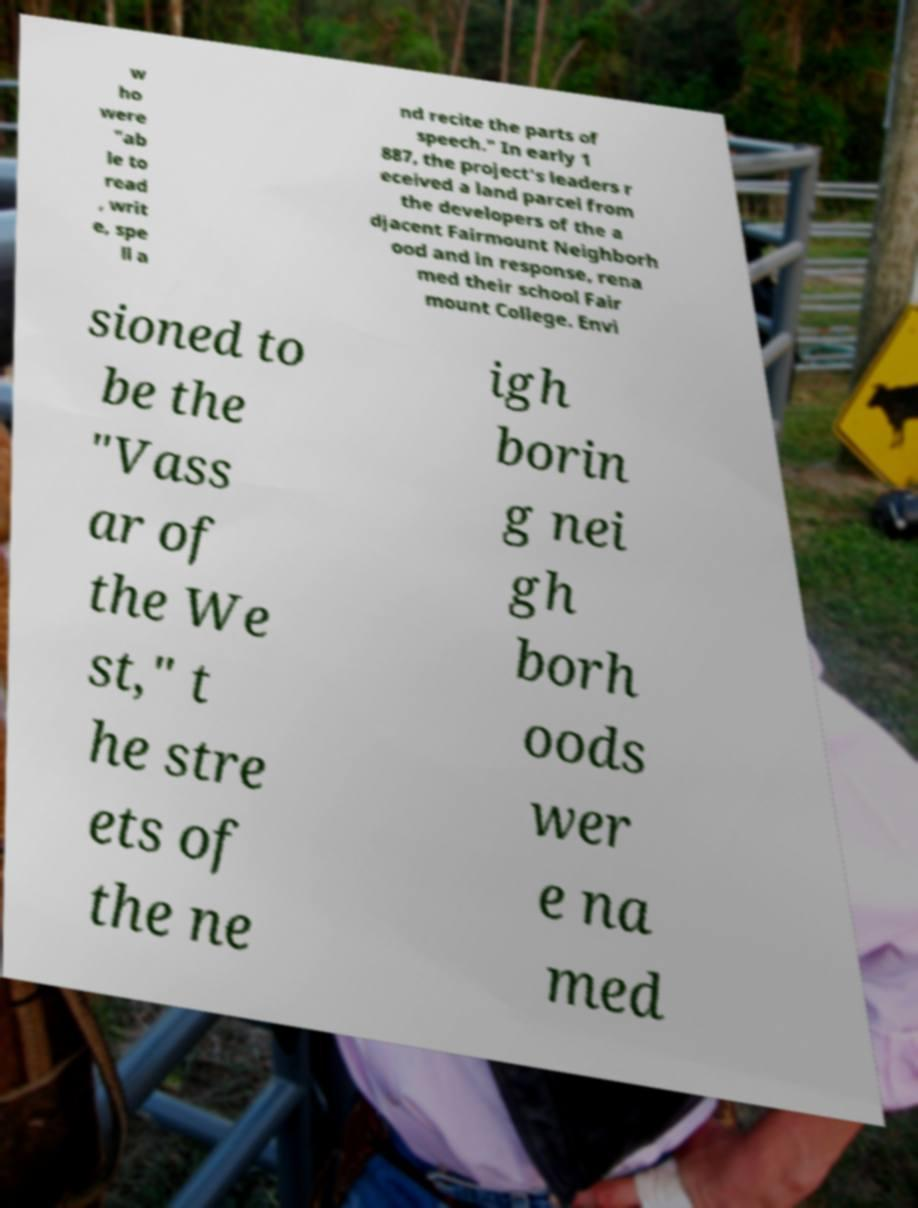Can you read and provide the text displayed in the image?This photo seems to have some interesting text. Can you extract and type it out for me? w ho were "ab le to read , writ e, spe ll a nd recite the parts of speech." In early 1 887, the project's leaders r eceived a land parcel from the developers of the a djacent Fairmount Neighborh ood and in response, rena med their school Fair mount College. Envi sioned to be the "Vass ar of the We st," t he stre ets of the ne igh borin g nei gh borh oods wer e na med 